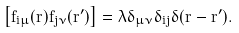<formula> <loc_0><loc_0><loc_500><loc_500>\left [ f _ { i \mu } ( { r } ) f _ { j \nu } ( { r } ^ { \prime } ) \right ] = \lambda \delta _ { \mu \nu } \delta _ { i j } \delta ( { r } - { r } ^ { \prime } ) .</formula> 